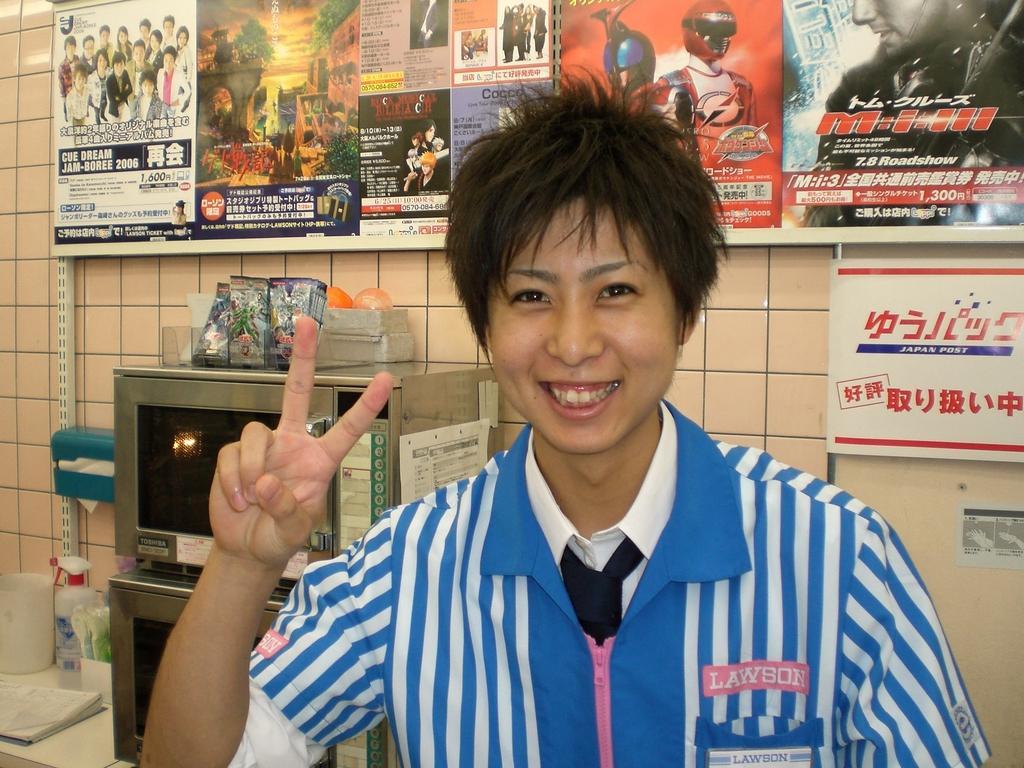Could you give a brief overview of what you see in this image? In this image I can see the person. To the left I can see the microwave ovens and some objects on it. I can also see the bottle and some objects on the white color surface. In the background I can see many boards to the wall. 